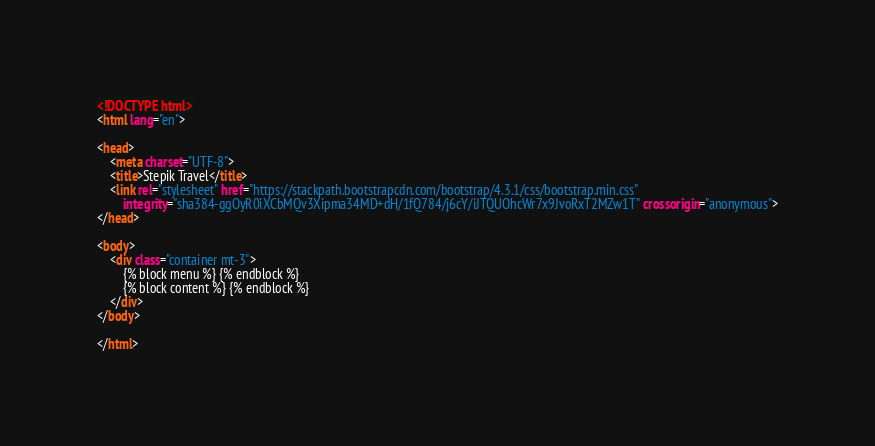Convert code to text. <code><loc_0><loc_0><loc_500><loc_500><_HTML_><!DOCTYPE html>
<html lang="en">

<head>
    <meta charset="UTF-8">
    <title>Stepik Travel</title>
    <link rel="stylesheet" href="https://stackpath.bootstrapcdn.com/bootstrap/4.3.1/css/bootstrap.min.css"
        integrity="sha384-ggOyR0iXCbMQv3Xipma34MD+dH/1fQ784/j6cY/iJTQUOhcWr7x9JvoRxT2MZw1T" crossorigin="anonymous">
</head>

<body>
    <div class="container mt-3">
        {% block menu %} {% endblock %}
        {% block content %} {% endblock %}
    </div>
</body>

</html></code> 